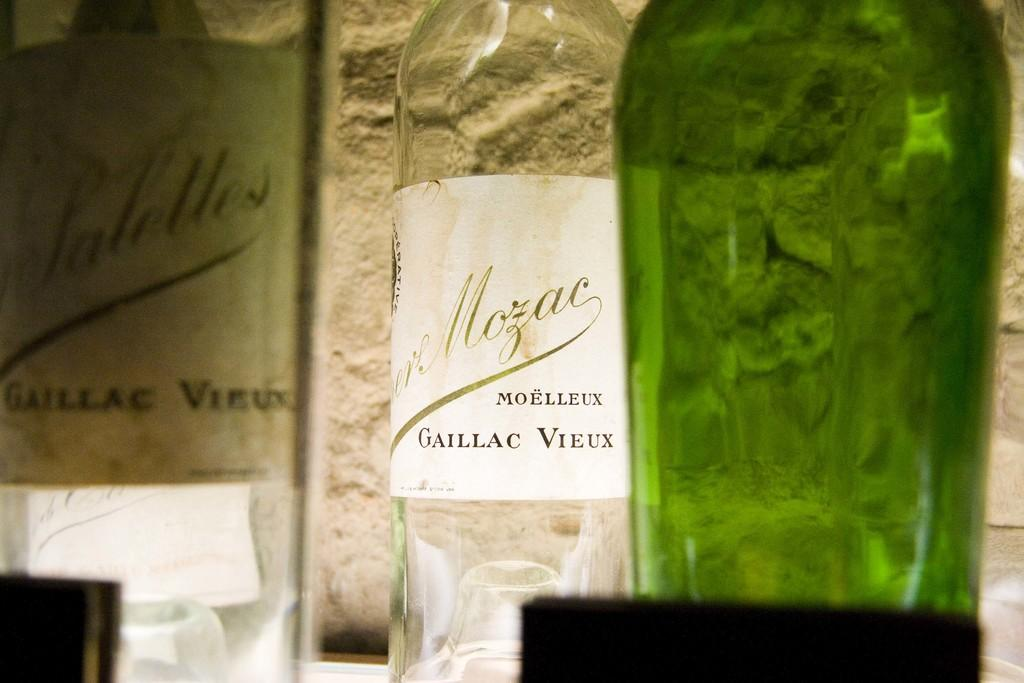<image>
Offer a succinct explanation of the picture presented. Clear wine bottle that is named "Moelleux Gaillac Vieux". 